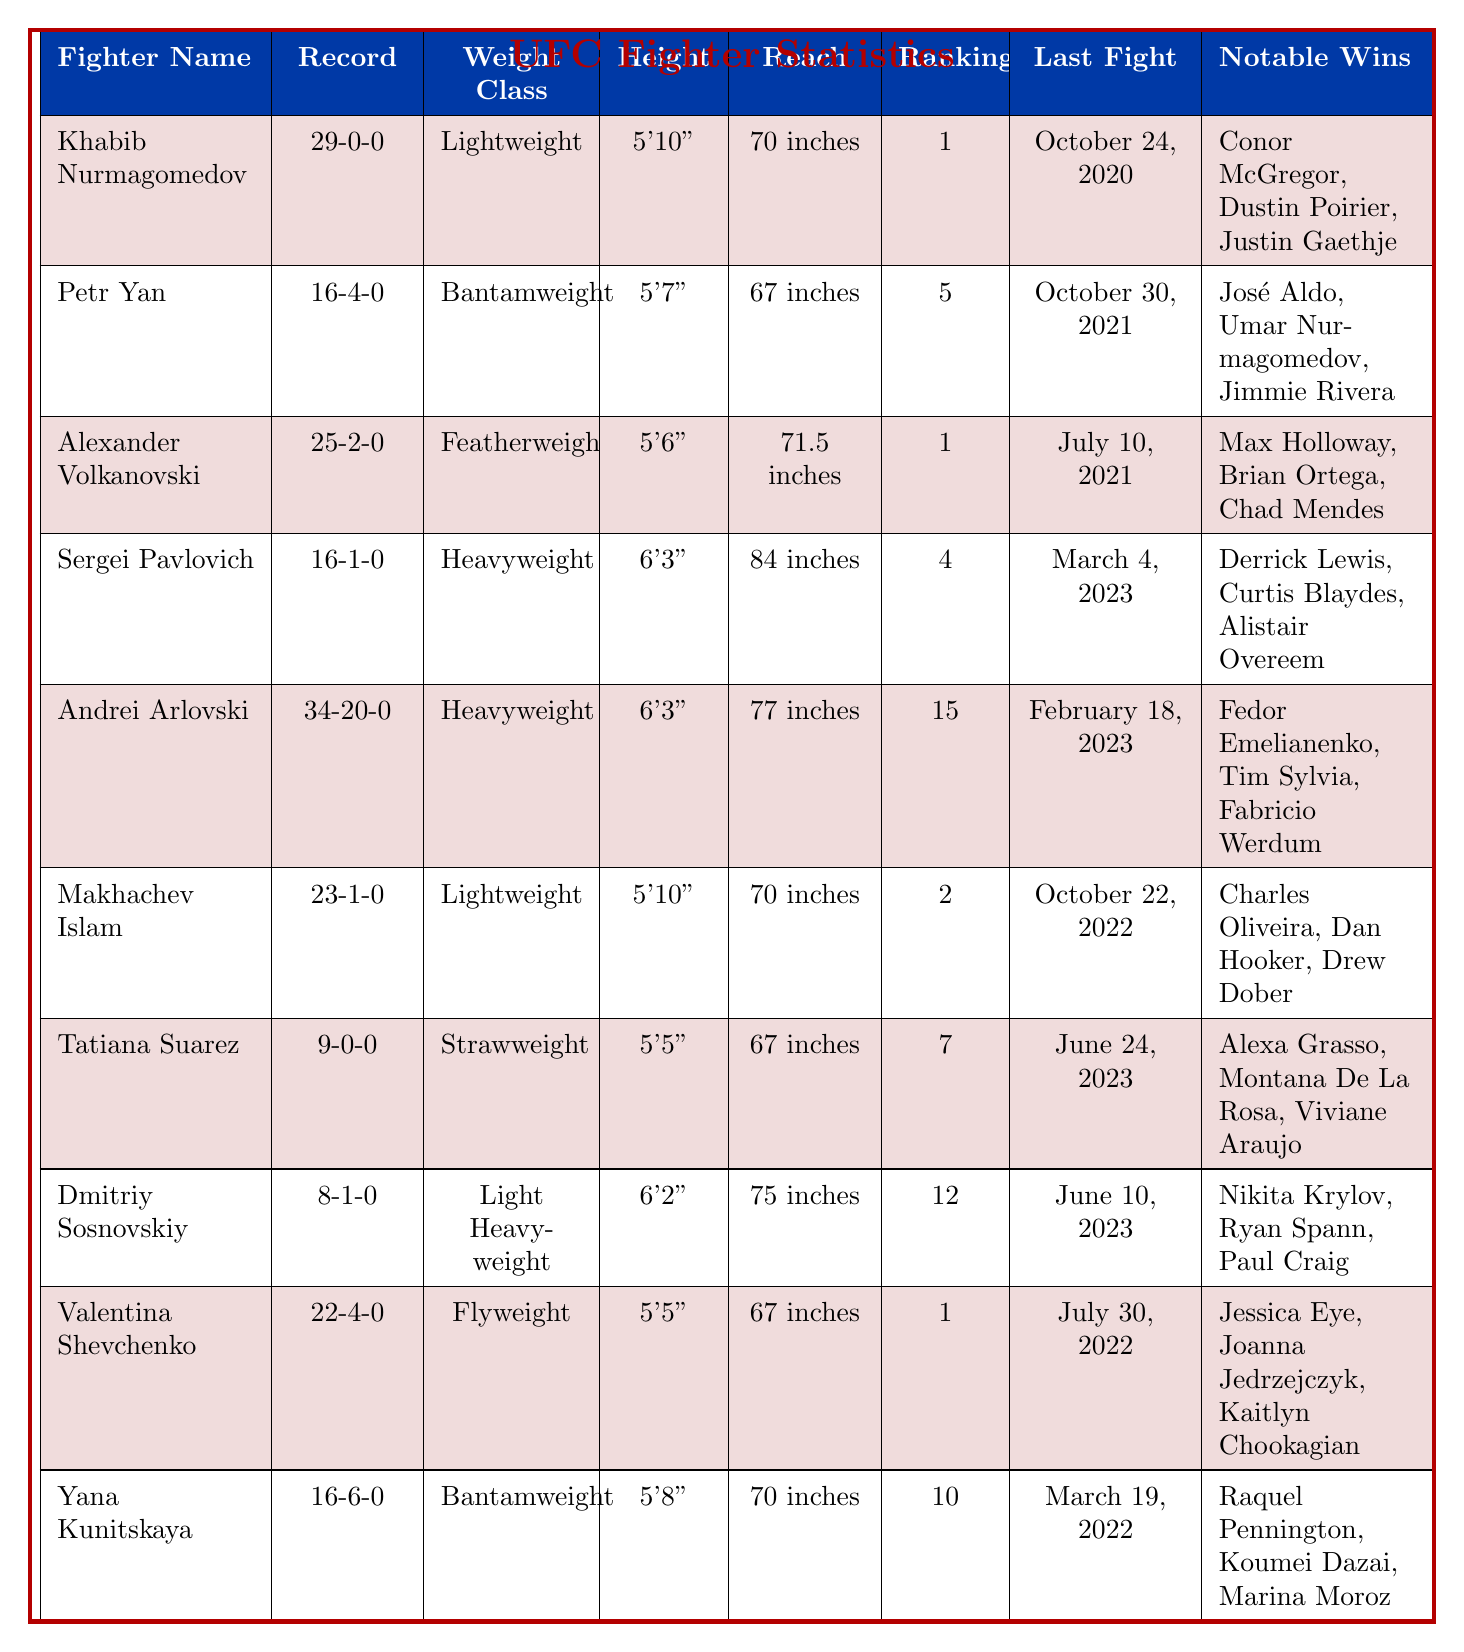What is Khabib Nurmagomedov's fight record? The fight record for Khabib Nurmagomedov is listed in the table as 29-0-0.
Answer: 29-0-0 Which fighter has the highest reach? The reach of each fighter is compared; Sergei Pavlovich has the highest reach at 84 inches.
Answer: 84 inches How many notable wins does Alexander Volkanovski have? The table shows that Alexander Volkanovski has three notable wins mentioned: Max Holloway, Brian Ortega, and Chad Mendes.
Answer: 3 What is the weight class of Petr Yan? The table shows that Petr Yan competes in the Bantamweight weight class.
Answer: Bantamweight Is Makhachev Islam ranked higher than Andrei Arlovski? Comparing the current rankings in the table, Makhachev Islam is ranked 2, while Andrei Arlovski is ranked 15. Thus, Makhachev Islam is ranked higher.
Answer: Yes How many fighters are in the Heavyweight class? The table lists two fighters in the Heavyweight class: Sergei Pavlovich and Andrei Arlovski.
Answer: 2 What was the last fight date for Valentina Shevchenko? The last fight date for Valentina Shevchenko is provided in the table as July 30, 2022.
Answer: July 30, 2022 What is the average current ranking of the fighters in the table? The current rankings are 1, 5, 1, 4, 15, 2, 7, 12, 1, and 10. Summing these gives 58, and dividing by the number of fighters (10) gives an average of 5.8.
Answer: 5.8 Which fighter has the most recent fight? By comparing the 'Last Fight' date, Sergei Pavlovich fought last on March 4, 2023, which is the most recent date among all listed fighters.
Answer: March 4, 2023 Has Tatiana Suarez ever lost a fight? Looking at the record for Tatiana Suarez, it shows 9-0-0, indicating she has never lost a fight.
Answer: No 